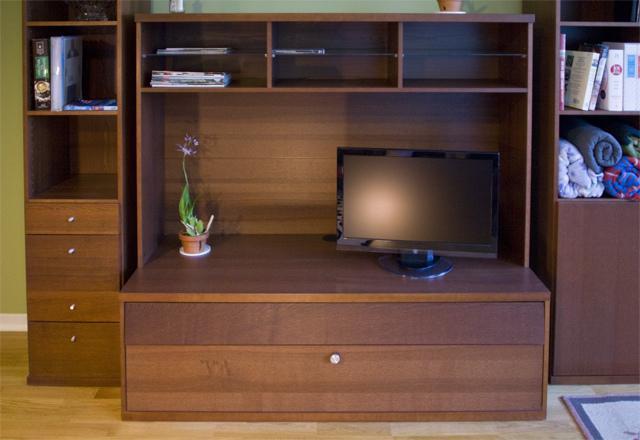How many drawers are shown?
Give a very brief answer. 5. How many plants are in the picture?
Give a very brief answer. 1. How many bottles of soap are by the sinks?
Give a very brief answer. 0. 